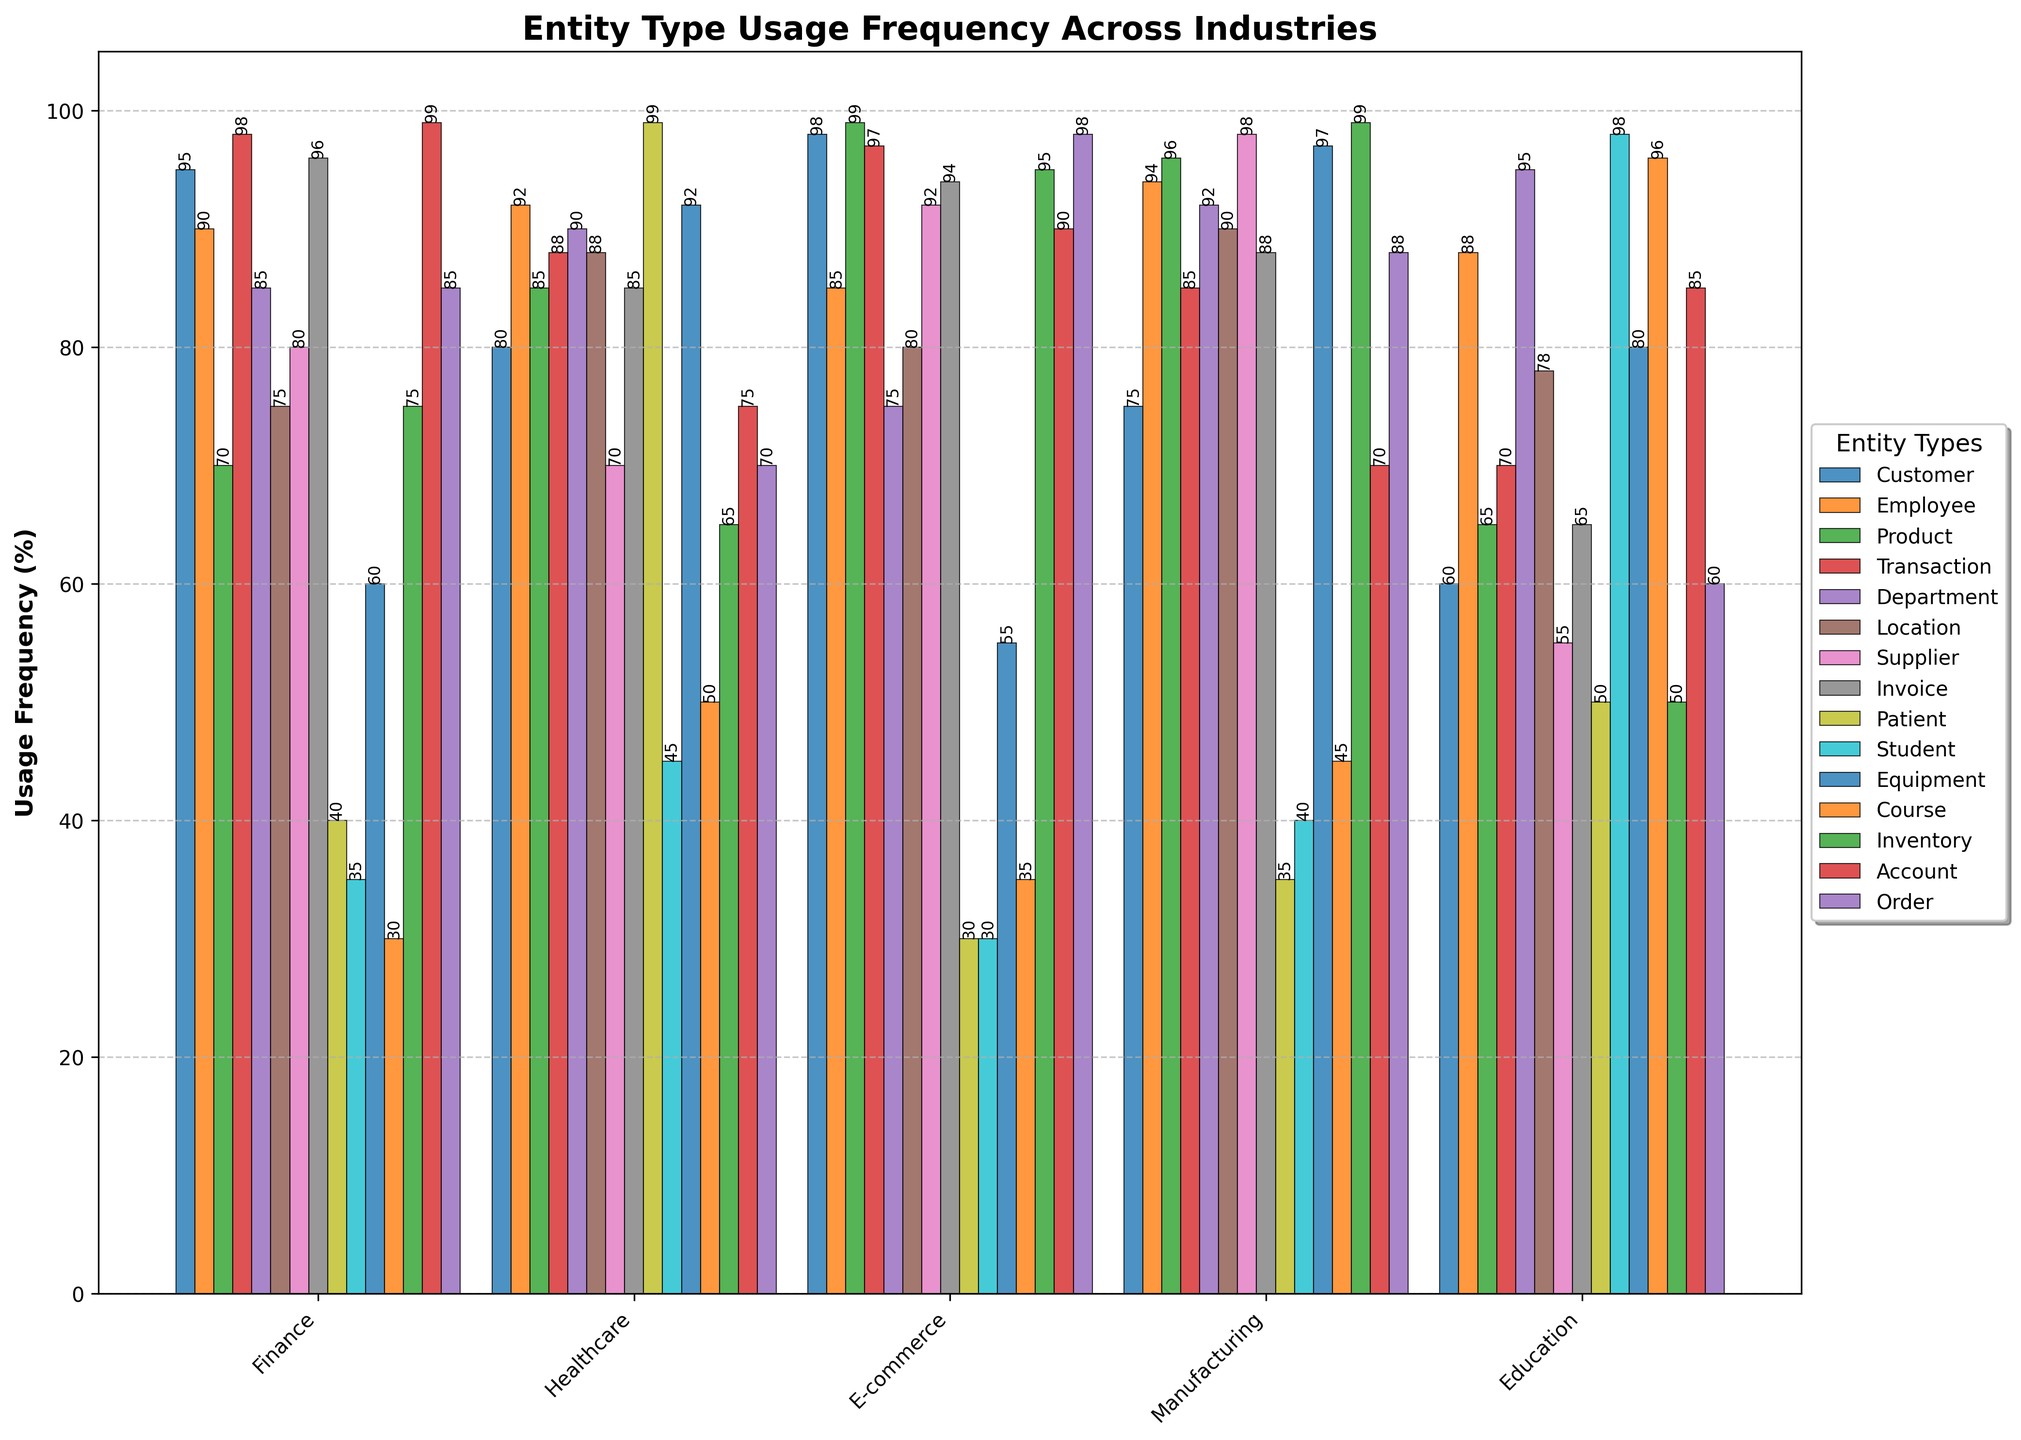What's the most frequently used entity type in the Finance industry? By examining the heights of the bars for each entity type under the Finance category, we observe that 'Account' with a frequency of 99% is the highest.
Answer: Account Which entity type has the lowest usage frequency in Healthcare? By looking at the bars under the Healthcare category, 'Supplier' with a 70% usage frequency is the lowest.
Answer: Supplier What is the average usage frequency of the 'Product' entity type across all industries? The frequencies of the 'Product' entity type are (70, 85, 99, 96, 65). Summing these gives 415. Dividing by the number of industries (5) gives 83.
Answer: 83 Which industry uses the 'Patient' entity type the most? Looking at the heights of the bars for the 'Patient' entity type across industries, we see that Healthcare has the tallest bar with a value of 99%.
Answer: Healthcare How much more frequently is the 'Customer' entity type used in Finance compared to Education? The 'Customer' entity type usage in Finance is 95%, while in Education, it is 60%. The difference is 95 - 60 = 35.
Answer: 35 Which two entity types share the same usage frequency in two different industries? 'Employee' in Finance and 'Patient' in Healthcare both have a usage frequency of 92%. 'Customer' in Manufacturing and 'Transaction' in Finance both have usage frequencies of 99%. For simplicity, we pick: 'Employee' and 'Patient' with both having 92%.
Answer: Employee and Patient What is the total usage frequency of the 'Invoice' entity type across Healthcare and Manufacturing? The 'Invoice' entity type has usage frequencies of 85% in Healthcare and 88% in Manufacturing. The total is 85 + 88 = 173.
Answer: 173 Compare the usage of 'Equipment' between Manufacturing and Finance. In Finance, 'Equipment' has a usage frequency of 60%; in Manufacturing, it has 97%. So, Manufacturing uses it more by 37 (97-60).
Answer: 37 Which industry has the most even distribution of entity type usages? To find this, we look for the industry where the heights of the bars are most similar. E-commerce and Healthcare both have relatively even heights across most entities. After comparison, Healthcare seems the most even.
Answer: Healthcare What is the median usage frequency of entity types in the E-commerce industry? The frequency values in E-commerce are (98, 85, 99, 97, 75, 80, 92, 94, 30, 30, 55, 35, 95, 90, 98). Arranging these in ascending order: (30, 30, 35, 55, 75, 80, 85, 90, 92, 94, 95, 97, 98, 98, 99). The median is the middle value: 90.
Answer: 90 